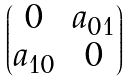<formula> <loc_0><loc_0><loc_500><loc_500>\begin{pmatrix} 0 & a _ { 0 1 } \\ a _ { 1 0 } & 0 \end{pmatrix}</formula> 